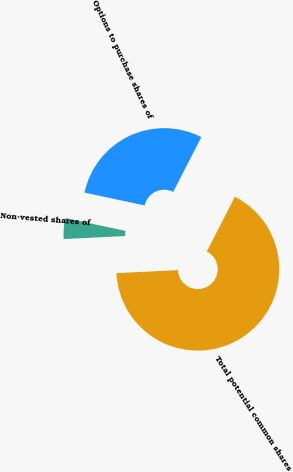<chart> <loc_0><loc_0><loc_500><loc_500><pie_chart><fcel>Options to purchase shares of<fcel>Non-vested shares of<fcel>Total potential common shares<nl><fcel>29.18%<fcel>4.13%<fcel>66.68%<nl></chart> 